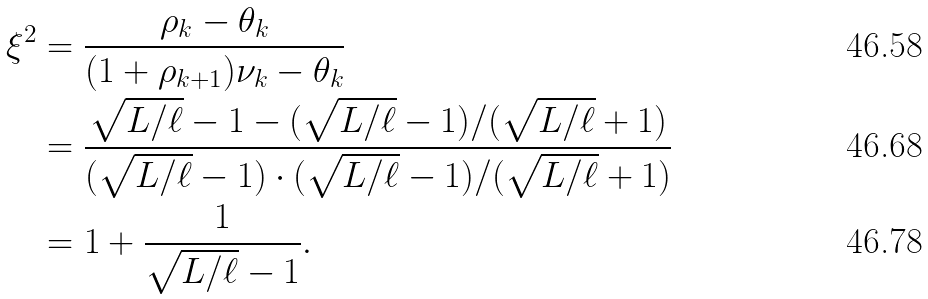<formula> <loc_0><loc_0><loc_500><loc_500>\xi ^ { 2 } & = \frac { \rho _ { k } - \theta _ { k } } { ( 1 + \rho _ { k + 1 } ) \nu _ { k } - \theta _ { k } } \\ & = \frac { \sqrt { L / \ell } - 1 - ( \sqrt { L / \ell } - 1 ) / ( \sqrt { L / \ell } + 1 ) } { ( \sqrt { L / \ell } - 1 ) \cdot ( \sqrt { L / \ell } - 1 ) / ( \sqrt { L / \ell } + 1 ) } \\ & = 1 + \frac { 1 } { \sqrt { L / \ell } - 1 } .</formula> 